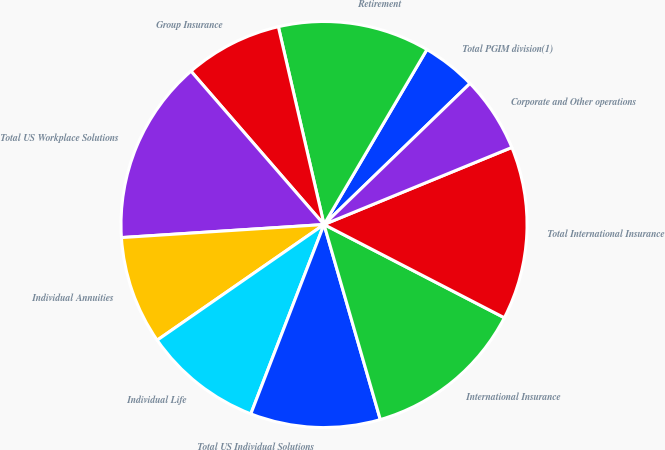Convert chart to OTSL. <chart><loc_0><loc_0><loc_500><loc_500><pie_chart><fcel>Total PGIM division(1)<fcel>Retirement<fcel>Group Insurance<fcel>Total US Workplace Solutions<fcel>Individual Annuities<fcel>Individual Life<fcel>Total US Individual Solutions<fcel>International Insurance<fcel>Total International Insurance<fcel>Corporate and Other operations<nl><fcel>4.31%<fcel>12.07%<fcel>7.76%<fcel>14.65%<fcel>8.62%<fcel>9.48%<fcel>10.34%<fcel>12.93%<fcel>13.79%<fcel>6.03%<nl></chart> 